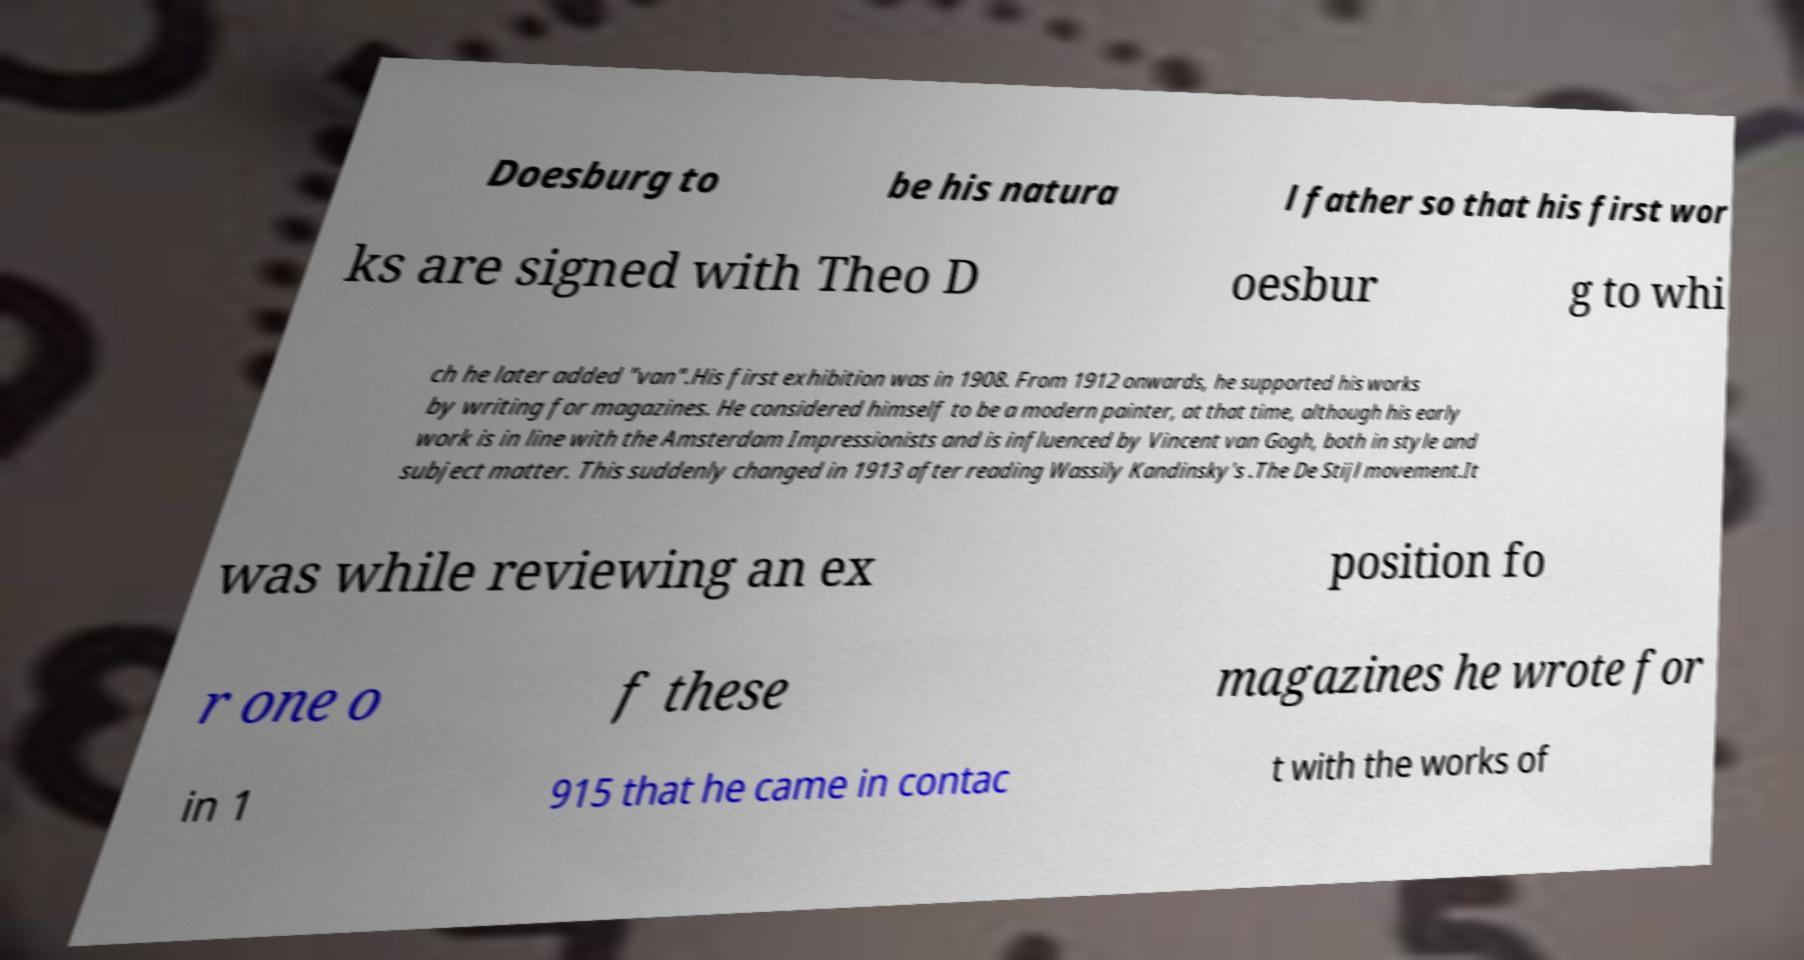There's text embedded in this image that I need extracted. Can you transcribe it verbatim? Doesburg to be his natura l father so that his first wor ks are signed with Theo D oesbur g to whi ch he later added "van".His first exhibition was in 1908. From 1912 onwards, he supported his works by writing for magazines. He considered himself to be a modern painter, at that time, although his early work is in line with the Amsterdam Impressionists and is influenced by Vincent van Gogh, both in style and subject matter. This suddenly changed in 1913 after reading Wassily Kandinsky's .The De Stijl movement.It was while reviewing an ex position fo r one o f these magazines he wrote for in 1 915 that he came in contac t with the works of 